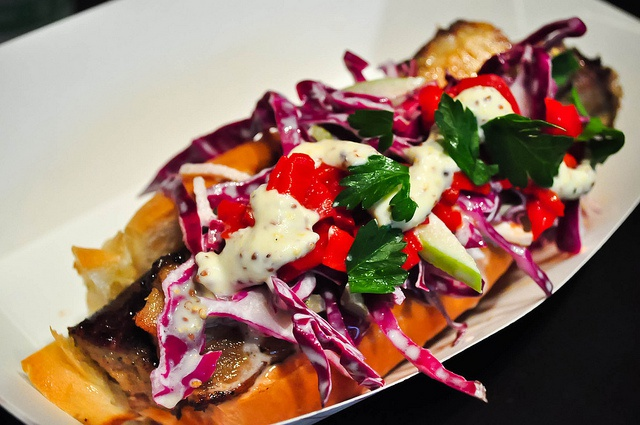Describe the objects in this image and their specific colors. I can see sandwich in black, maroon, and beige tones and hot dog in black, maroon, and beige tones in this image. 